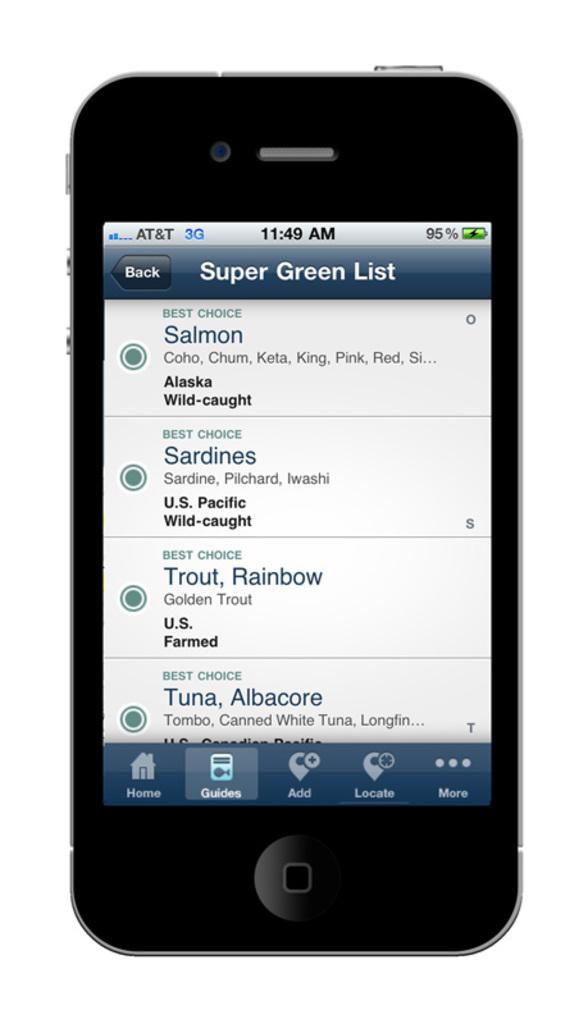What is the name of the category in the super green list?
Your response must be concise. Best choice. What type of list is this?
Ensure brevity in your answer.  Super green. 